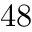<formula> <loc_0><loc_0><loc_500><loc_500>4 8</formula> 